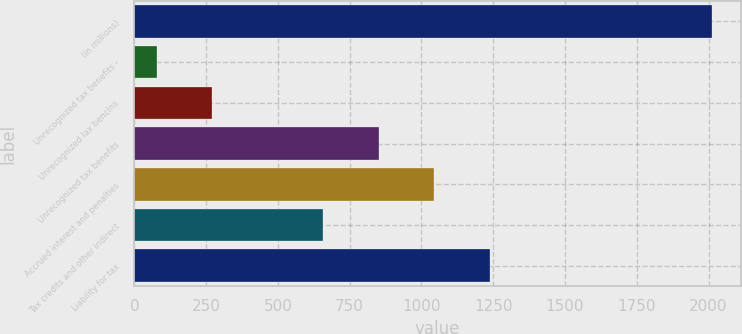<chart> <loc_0><loc_0><loc_500><loc_500><bar_chart><fcel>(in millions)<fcel>Unrecognized tax benefits -<fcel>Unrecognized lax benclns<fcel>Unrecognized tax benefits<fcel>Accrued interest and penalties<fcel>Tax credits and other indirect<fcel>Liability for tax<nl><fcel>2011<fcel>78<fcel>271.3<fcel>851.2<fcel>1044.5<fcel>657.9<fcel>1237.8<nl></chart> 